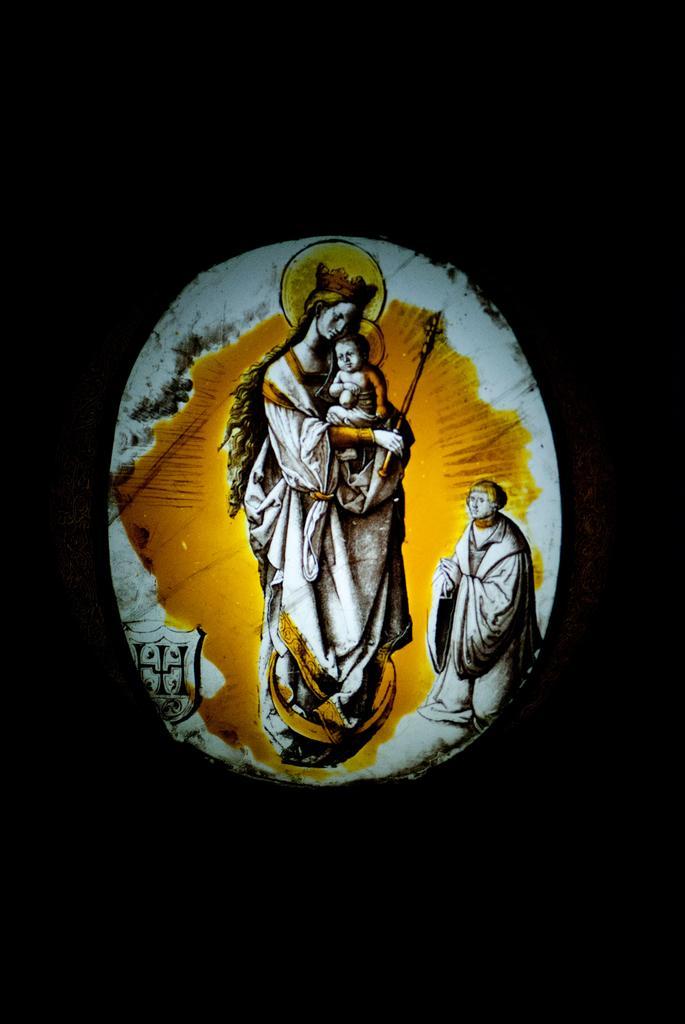Could you give a brief overview of what you see in this image? In this image we can see some images of people, and the background is black in color. 